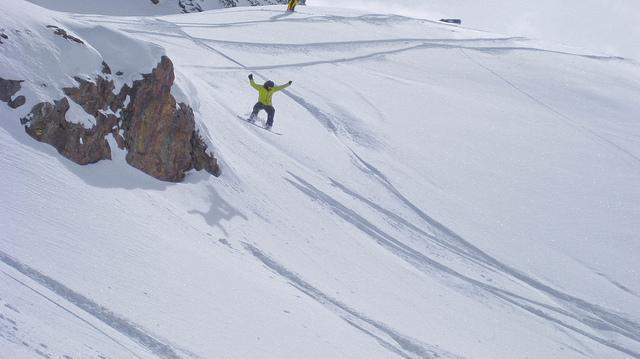How many cats are shown?
Give a very brief answer. 0. 